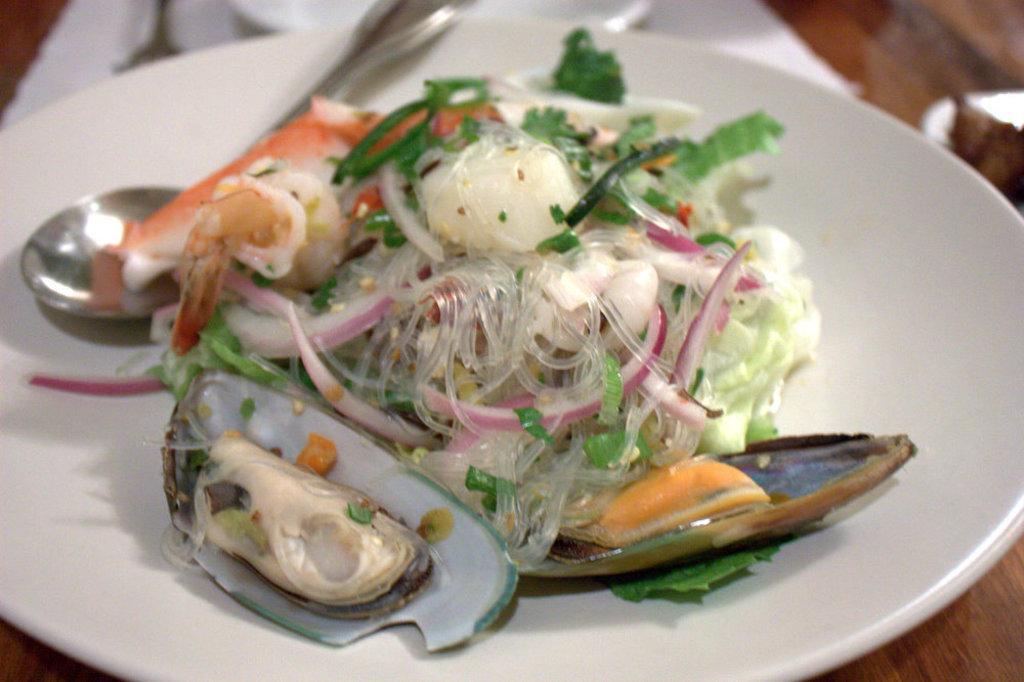In one or two sentences, can you explain what this image depicts? In this picture we can see food in the plate. We can see spoon, tissue papers and objects and wooden platform. 